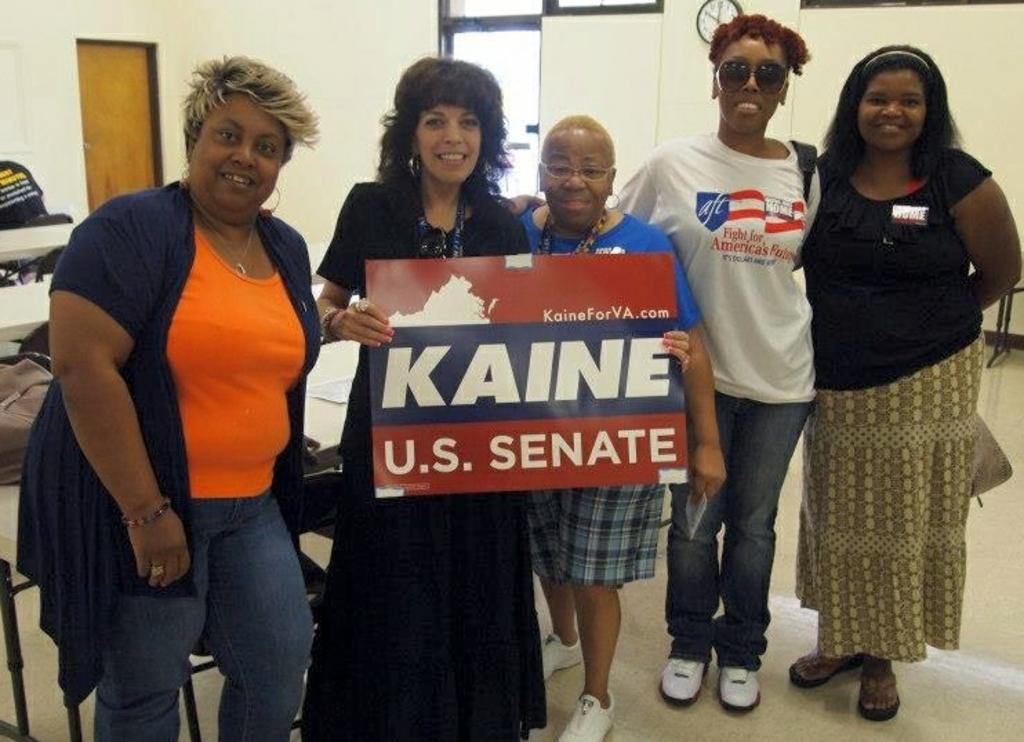What is the main subject of the image? The main subject of the image is a group of people. Can you describe the people in the image? The people in the image are of various age factors. What are the people holding in the image? The people are holding a board with text on it. What other objects can be seen in the image? There is a clock visible in the image, and there is a door on the left side of the image. What type of rings can be seen on the people's fingers in the image? There are no rings visible on the people's fingers in the image. What color is the ink used for the text on the board? The image does not provide information about the color of the ink used for the text on the board. 